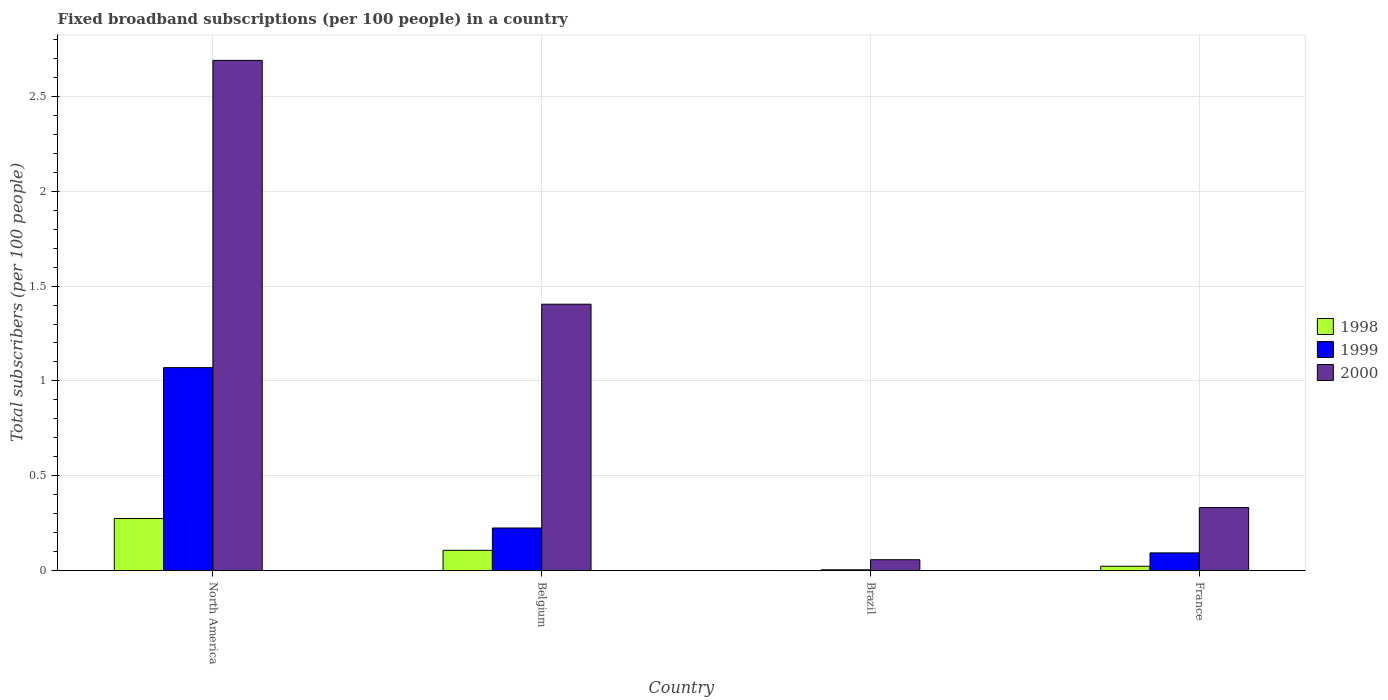How many groups of bars are there?
Provide a succinct answer. 4. Are the number of bars per tick equal to the number of legend labels?
Offer a terse response. Yes. How many bars are there on the 3rd tick from the left?
Provide a succinct answer. 3. How many bars are there on the 2nd tick from the right?
Offer a very short reply. 3. In how many cases, is the number of bars for a given country not equal to the number of legend labels?
Give a very brief answer. 0. What is the number of broadband subscriptions in 1999 in France?
Provide a succinct answer. 0.09. Across all countries, what is the maximum number of broadband subscriptions in 2000?
Your answer should be compact. 2.69. Across all countries, what is the minimum number of broadband subscriptions in 1998?
Your answer should be compact. 0. In which country was the number of broadband subscriptions in 1999 minimum?
Ensure brevity in your answer.  Brazil. What is the total number of broadband subscriptions in 1999 in the graph?
Offer a very short reply. 1.39. What is the difference between the number of broadband subscriptions in 1998 in Brazil and that in France?
Offer a terse response. -0.02. What is the difference between the number of broadband subscriptions in 1998 in North America and the number of broadband subscriptions in 2000 in Brazil?
Give a very brief answer. 0.22. What is the average number of broadband subscriptions in 1998 per country?
Your answer should be very brief. 0.1. What is the difference between the number of broadband subscriptions of/in 1998 and number of broadband subscriptions of/in 1999 in North America?
Offer a very short reply. -0.8. In how many countries, is the number of broadband subscriptions in 2000 greater than 0.4?
Offer a terse response. 2. What is the ratio of the number of broadband subscriptions in 1998 in Belgium to that in Brazil?
Provide a short and direct response. 181.1. Is the number of broadband subscriptions in 2000 in Belgium less than that in North America?
Give a very brief answer. Yes. Is the difference between the number of broadband subscriptions in 1998 in Belgium and North America greater than the difference between the number of broadband subscriptions in 1999 in Belgium and North America?
Offer a terse response. Yes. What is the difference between the highest and the second highest number of broadband subscriptions in 2000?
Provide a succinct answer. -1.07. What is the difference between the highest and the lowest number of broadband subscriptions in 2000?
Your response must be concise. 2.63. In how many countries, is the number of broadband subscriptions in 1998 greater than the average number of broadband subscriptions in 1998 taken over all countries?
Ensure brevity in your answer.  2. Is the sum of the number of broadband subscriptions in 1998 in Brazil and France greater than the maximum number of broadband subscriptions in 1999 across all countries?
Your answer should be very brief. No. How many bars are there?
Make the answer very short. 12. How many countries are there in the graph?
Keep it short and to the point. 4. Does the graph contain grids?
Give a very brief answer. Yes. What is the title of the graph?
Offer a terse response. Fixed broadband subscriptions (per 100 people) in a country. What is the label or title of the X-axis?
Keep it short and to the point. Country. What is the label or title of the Y-axis?
Your answer should be compact. Total subscribers (per 100 people). What is the Total subscribers (per 100 people) of 1998 in North America?
Make the answer very short. 0.27. What is the Total subscribers (per 100 people) of 1999 in North America?
Give a very brief answer. 1.07. What is the Total subscribers (per 100 people) in 2000 in North America?
Make the answer very short. 2.69. What is the Total subscribers (per 100 people) in 1998 in Belgium?
Your response must be concise. 0.11. What is the Total subscribers (per 100 people) in 1999 in Belgium?
Your answer should be very brief. 0.22. What is the Total subscribers (per 100 people) of 2000 in Belgium?
Keep it short and to the point. 1.4. What is the Total subscribers (per 100 people) of 1998 in Brazil?
Give a very brief answer. 0. What is the Total subscribers (per 100 people) of 1999 in Brazil?
Provide a short and direct response. 0. What is the Total subscribers (per 100 people) of 2000 in Brazil?
Make the answer very short. 0.06. What is the Total subscribers (per 100 people) in 1998 in France?
Your response must be concise. 0.02. What is the Total subscribers (per 100 people) of 1999 in France?
Offer a terse response. 0.09. What is the Total subscribers (per 100 people) of 2000 in France?
Offer a terse response. 0.33. Across all countries, what is the maximum Total subscribers (per 100 people) of 1998?
Give a very brief answer. 0.27. Across all countries, what is the maximum Total subscribers (per 100 people) in 1999?
Make the answer very short. 1.07. Across all countries, what is the maximum Total subscribers (per 100 people) in 2000?
Make the answer very short. 2.69. Across all countries, what is the minimum Total subscribers (per 100 people) in 1998?
Your answer should be very brief. 0. Across all countries, what is the minimum Total subscribers (per 100 people) of 1999?
Keep it short and to the point. 0. Across all countries, what is the minimum Total subscribers (per 100 people) in 2000?
Give a very brief answer. 0.06. What is the total Total subscribers (per 100 people) in 1998 in the graph?
Your answer should be very brief. 0.4. What is the total Total subscribers (per 100 people) in 1999 in the graph?
Offer a terse response. 1.39. What is the total Total subscribers (per 100 people) of 2000 in the graph?
Provide a short and direct response. 4.48. What is the difference between the Total subscribers (per 100 people) of 1998 in North America and that in Belgium?
Offer a very short reply. 0.17. What is the difference between the Total subscribers (per 100 people) in 1999 in North America and that in Belgium?
Keep it short and to the point. 0.85. What is the difference between the Total subscribers (per 100 people) of 2000 in North America and that in Belgium?
Provide a succinct answer. 1.29. What is the difference between the Total subscribers (per 100 people) in 1998 in North America and that in Brazil?
Offer a terse response. 0.27. What is the difference between the Total subscribers (per 100 people) in 1999 in North America and that in Brazil?
Provide a short and direct response. 1.07. What is the difference between the Total subscribers (per 100 people) in 2000 in North America and that in Brazil?
Keep it short and to the point. 2.63. What is the difference between the Total subscribers (per 100 people) in 1998 in North America and that in France?
Your response must be concise. 0.25. What is the difference between the Total subscribers (per 100 people) in 1999 in North America and that in France?
Keep it short and to the point. 0.98. What is the difference between the Total subscribers (per 100 people) in 2000 in North America and that in France?
Your answer should be compact. 2.36. What is the difference between the Total subscribers (per 100 people) of 1998 in Belgium and that in Brazil?
Your answer should be very brief. 0.11. What is the difference between the Total subscribers (per 100 people) in 1999 in Belgium and that in Brazil?
Offer a very short reply. 0.22. What is the difference between the Total subscribers (per 100 people) of 2000 in Belgium and that in Brazil?
Keep it short and to the point. 1.35. What is the difference between the Total subscribers (per 100 people) of 1998 in Belgium and that in France?
Ensure brevity in your answer.  0.08. What is the difference between the Total subscribers (per 100 people) of 1999 in Belgium and that in France?
Offer a terse response. 0.13. What is the difference between the Total subscribers (per 100 people) in 2000 in Belgium and that in France?
Make the answer very short. 1.07. What is the difference between the Total subscribers (per 100 people) of 1998 in Brazil and that in France?
Give a very brief answer. -0.02. What is the difference between the Total subscribers (per 100 people) in 1999 in Brazil and that in France?
Your answer should be very brief. -0.09. What is the difference between the Total subscribers (per 100 people) in 2000 in Brazil and that in France?
Your answer should be compact. -0.27. What is the difference between the Total subscribers (per 100 people) of 1998 in North America and the Total subscribers (per 100 people) of 1999 in Belgium?
Your response must be concise. 0.05. What is the difference between the Total subscribers (per 100 people) in 1998 in North America and the Total subscribers (per 100 people) in 2000 in Belgium?
Ensure brevity in your answer.  -1.13. What is the difference between the Total subscribers (per 100 people) in 1999 in North America and the Total subscribers (per 100 people) in 2000 in Belgium?
Give a very brief answer. -0.33. What is the difference between the Total subscribers (per 100 people) in 1998 in North America and the Total subscribers (per 100 people) in 1999 in Brazil?
Your answer should be compact. 0.27. What is the difference between the Total subscribers (per 100 people) in 1998 in North America and the Total subscribers (per 100 people) in 2000 in Brazil?
Provide a succinct answer. 0.22. What is the difference between the Total subscribers (per 100 people) of 1999 in North America and the Total subscribers (per 100 people) of 2000 in Brazil?
Your response must be concise. 1.01. What is the difference between the Total subscribers (per 100 people) of 1998 in North America and the Total subscribers (per 100 people) of 1999 in France?
Your response must be concise. 0.18. What is the difference between the Total subscribers (per 100 people) of 1998 in North America and the Total subscribers (per 100 people) of 2000 in France?
Provide a succinct answer. -0.06. What is the difference between the Total subscribers (per 100 people) in 1999 in North America and the Total subscribers (per 100 people) in 2000 in France?
Ensure brevity in your answer.  0.74. What is the difference between the Total subscribers (per 100 people) in 1998 in Belgium and the Total subscribers (per 100 people) in 1999 in Brazil?
Your answer should be compact. 0.1. What is the difference between the Total subscribers (per 100 people) in 1998 in Belgium and the Total subscribers (per 100 people) in 2000 in Brazil?
Ensure brevity in your answer.  0.05. What is the difference between the Total subscribers (per 100 people) in 1999 in Belgium and the Total subscribers (per 100 people) in 2000 in Brazil?
Offer a very short reply. 0.17. What is the difference between the Total subscribers (per 100 people) in 1998 in Belgium and the Total subscribers (per 100 people) in 1999 in France?
Offer a terse response. 0.01. What is the difference between the Total subscribers (per 100 people) of 1998 in Belgium and the Total subscribers (per 100 people) of 2000 in France?
Ensure brevity in your answer.  -0.23. What is the difference between the Total subscribers (per 100 people) of 1999 in Belgium and the Total subscribers (per 100 people) of 2000 in France?
Keep it short and to the point. -0.11. What is the difference between the Total subscribers (per 100 people) in 1998 in Brazil and the Total subscribers (per 100 people) in 1999 in France?
Ensure brevity in your answer.  -0.09. What is the difference between the Total subscribers (per 100 people) of 1998 in Brazil and the Total subscribers (per 100 people) of 2000 in France?
Make the answer very short. -0.33. What is the difference between the Total subscribers (per 100 people) of 1999 in Brazil and the Total subscribers (per 100 people) of 2000 in France?
Provide a succinct answer. -0.33. What is the average Total subscribers (per 100 people) in 1998 per country?
Provide a succinct answer. 0.1. What is the average Total subscribers (per 100 people) of 1999 per country?
Your response must be concise. 0.35. What is the average Total subscribers (per 100 people) in 2000 per country?
Your answer should be very brief. 1.12. What is the difference between the Total subscribers (per 100 people) in 1998 and Total subscribers (per 100 people) in 1999 in North America?
Your answer should be very brief. -0.8. What is the difference between the Total subscribers (per 100 people) in 1998 and Total subscribers (per 100 people) in 2000 in North America?
Your response must be concise. -2.42. What is the difference between the Total subscribers (per 100 people) of 1999 and Total subscribers (per 100 people) of 2000 in North America?
Your answer should be very brief. -1.62. What is the difference between the Total subscribers (per 100 people) of 1998 and Total subscribers (per 100 people) of 1999 in Belgium?
Provide a succinct answer. -0.12. What is the difference between the Total subscribers (per 100 people) in 1998 and Total subscribers (per 100 people) in 2000 in Belgium?
Your response must be concise. -1.3. What is the difference between the Total subscribers (per 100 people) of 1999 and Total subscribers (per 100 people) of 2000 in Belgium?
Your response must be concise. -1.18. What is the difference between the Total subscribers (per 100 people) of 1998 and Total subscribers (per 100 people) of 1999 in Brazil?
Your response must be concise. -0. What is the difference between the Total subscribers (per 100 people) in 1998 and Total subscribers (per 100 people) in 2000 in Brazil?
Your answer should be very brief. -0.06. What is the difference between the Total subscribers (per 100 people) in 1999 and Total subscribers (per 100 people) in 2000 in Brazil?
Ensure brevity in your answer.  -0.05. What is the difference between the Total subscribers (per 100 people) in 1998 and Total subscribers (per 100 people) in 1999 in France?
Keep it short and to the point. -0.07. What is the difference between the Total subscribers (per 100 people) of 1998 and Total subscribers (per 100 people) of 2000 in France?
Offer a very short reply. -0.31. What is the difference between the Total subscribers (per 100 people) of 1999 and Total subscribers (per 100 people) of 2000 in France?
Provide a short and direct response. -0.24. What is the ratio of the Total subscribers (per 100 people) of 1998 in North America to that in Belgium?
Ensure brevity in your answer.  2.57. What is the ratio of the Total subscribers (per 100 people) of 1999 in North America to that in Belgium?
Keep it short and to the point. 4.76. What is the ratio of the Total subscribers (per 100 people) in 2000 in North America to that in Belgium?
Offer a very short reply. 1.92. What is the ratio of the Total subscribers (per 100 people) of 1998 in North America to that in Brazil?
Keep it short and to the point. 465.15. What is the ratio of the Total subscribers (per 100 people) of 1999 in North America to that in Brazil?
Ensure brevity in your answer.  262.9. What is the ratio of the Total subscribers (per 100 people) of 2000 in North America to that in Brazil?
Ensure brevity in your answer.  46.94. What is the ratio of the Total subscribers (per 100 people) of 1998 in North America to that in France?
Make the answer very short. 11.95. What is the ratio of the Total subscribers (per 100 people) in 1999 in North America to that in France?
Make the answer very short. 11.46. What is the ratio of the Total subscribers (per 100 people) in 2000 in North America to that in France?
Make the answer very short. 8.1. What is the ratio of the Total subscribers (per 100 people) in 1998 in Belgium to that in Brazil?
Ensure brevity in your answer.  181.1. What is the ratio of the Total subscribers (per 100 people) of 1999 in Belgium to that in Brazil?
Ensure brevity in your answer.  55.18. What is the ratio of the Total subscribers (per 100 people) in 2000 in Belgium to that in Brazil?
Offer a terse response. 24.51. What is the ratio of the Total subscribers (per 100 people) in 1998 in Belgium to that in France?
Your answer should be compact. 4.65. What is the ratio of the Total subscribers (per 100 people) in 1999 in Belgium to that in France?
Make the answer very short. 2.4. What is the ratio of the Total subscribers (per 100 people) of 2000 in Belgium to that in France?
Keep it short and to the point. 4.23. What is the ratio of the Total subscribers (per 100 people) of 1998 in Brazil to that in France?
Your response must be concise. 0.03. What is the ratio of the Total subscribers (per 100 people) of 1999 in Brazil to that in France?
Ensure brevity in your answer.  0.04. What is the ratio of the Total subscribers (per 100 people) in 2000 in Brazil to that in France?
Your answer should be very brief. 0.17. What is the difference between the highest and the second highest Total subscribers (per 100 people) of 1998?
Give a very brief answer. 0.17. What is the difference between the highest and the second highest Total subscribers (per 100 people) in 1999?
Keep it short and to the point. 0.85. What is the difference between the highest and the second highest Total subscribers (per 100 people) of 2000?
Make the answer very short. 1.29. What is the difference between the highest and the lowest Total subscribers (per 100 people) of 1998?
Keep it short and to the point. 0.27. What is the difference between the highest and the lowest Total subscribers (per 100 people) of 1999?
Your answer should be very brief. 1.07. What is the difference between the highest and the lowest Total subscribers (per 100 people) in 2000?
Your answer should be compact. 2.63. 